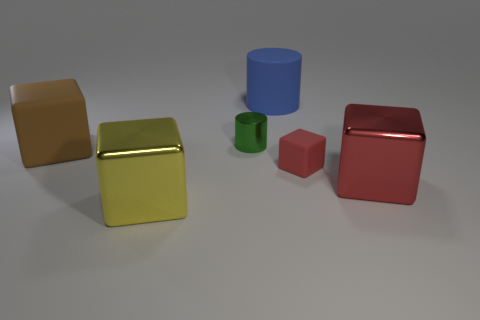Subtract all big yellow cubes. How many cubes are left? 3 Subtract 1 cylinders. How many cylinders are left? 1 Subtract all yellow cubes. How many cubes are left? 3 Add 1 tiny cylinders. How many objects exist? 7 Subtract 0 cyan balls. How many objects are left? 6 Subtract all cubes. How many objects are left? 2 Subtract all brown cubes. Subtract all red spheres. How many cubes are left? 3 Subtract all blue cubes. How many gray cylinders are left? 0 Subtract all large blue cylinders. Subtract all green shiny spheres. How many objects are left? 5 Add 5 metallic things. How many metallic things are left? 8 